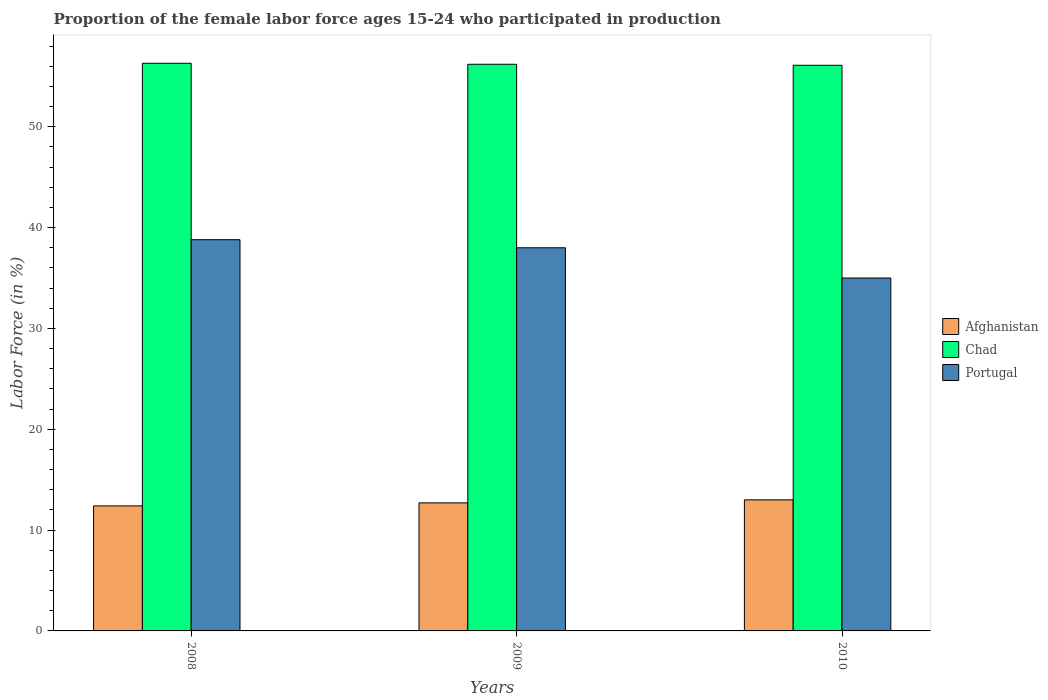How many different coloured bars are there?
Make the answer very short. 3. How many groups of bars are there?
Provide a short and direct response. 3. Are the number of bars on each tick of the X-axis equal?
Your answer should be very brief. Yes. What is the proportion of the female labor force who participated in production in Chad in 2008?
Provide a succinct answer. 56.3. Across all years, what is the maximum proportion of the female labor force who participated in production in Portugal?
Ensure brevity in your answer.  38.8. Across all years, what is the minimum proportion of the female labor force who participated in production in Chad?
Your answer should be compact. 56.1. In which year was the proportion of the female labor force who participated in production in Chad maximum?
Provide a short and direct response. 2008. What is the total proportion of the female labor force who participated in production in Chad in the graph?
Offer a very short reply. 168.6. What is the difference between the proportion of the female labor force who participated in production in Chad in 2008 and the proportion of the female labor force who participated in production in Portugal in 2009?
Your response must be concise. 18.3. What is the average proportion of the female labor force who participated in production in Portugal per year?
Give a very brief answer. 37.27. In the year 2008, what is the difference between the proportion of the female labor force who participated in production in Chad and proportion of the female labor force who participated in production in Afghanistan?
Provide a succinct answer. 43.9. In how many years, is the proportion of the female labor force who participated in production in Portugal greater than 22 %?
Give a very brief answer. 3. What is the ratio of the proportion of the female labor force who participated in production in Portugal in 2008 to that in 2010?
Provide a short and direct response. 1.11. Is the proportion of the female labor force who participated in production in Portugal in 2008 less than that in 2010?
Offer a very short reply. No. Is the difference between the proportion of the female labor force who participated in production in Chad in 2009 and 2010 greater than the difference between the proportion of the female labor force who participated in production in Afghanistan in 2009 and 2010?
Provide a short and direct response. Yes. What is the difference between the highest and the second highest proportion of the female labor force who participated in production in Chad?
Give a very brief answer. 0.1. What is the difference between the highest and the lowest proportion of the female labor force who participated in production in Chad?
Keep it short and to the point. 0.2. In how many years, is the proportion of the female labor force who participated in production in Afghanistan greater than the average proportion of the female labor force who participated in production in Afghanistan taken over all years?
Provide a succinct answer. 1. What does the 3rd bar from the right in 2009 represents?
Provide a succinct answer. Afghanistan. What is the difference between two consecutive major ticks on the Y-axis?
Keep it short and to the point. 10. Are the values on the major ticks of Y-axis written in scientific E-notation?
Offer a terse response. No. What is the title of the graph?
Keep it short and to the point. Proportion of the female labor force ages 15-24 who participated in production. What is the label or title of the X-axis?
Provide a short and direct response. Years. What is the Labor Force (in %) in Afghanistan in 2008?
Keep it short and to the point. 12.4. What is the Labor Force (in %) in Chad in 2008?
Your response must be concise. 56.3. What is the Labor Force (in %) in Portugal in 2008?
Ensure brevity in your answer.  38.8. What is the Labor Force (in %) of Afghanistan in 2009?
Your response must be concise. 12.7. What is the Labor Force (in %) of Chad in 2009?
Keep it short and to the point. 56.2. What is the Labor Force (in %) of Chad in 2010?
Ensure brevity in your answer.  56.1. Across all years, what is the maximum Labor Force (in %) of Afghanistan?
Provide a short and direct response. 13. Across all years, what is the maximum Labor Force (in %) of Chad?
Make the answer very short. 56.3. Across all years, what is the maximum Labor Force (in %) of Portugal?
Your answer should be very brief. 38.8. Across all years, what is the minimum Labor Force (in %) in Afghanistan?
Keep it short and to the point. 12.4. Across all years, what is the minimum Labor Force (in %) in Chad?
Provide a short and direct response. 56.1. What is the total Labor Force (in %) of Afghanistan in the graph?
Ensure brevity in your answer.  38.1. What is the total Labor Force (in %) in Chad in the graph?
Keep it short and to the point. 168.6. What is the total Labor Force (in %) of Portugal in the graph?
Ensure brevity in your answer.  111.8. What is the difference between the Labor Force (in %) of Afghanistan in 2008 and that in 2009?
Provide a short and direct response. -0.3. What is the difference between the Labor Force (in %) in Portugal in 2008 and that in 2010?
Provide a succinct answer. 3.8. What is the difference between the Labor Force (in %) of Chad in 2009 and that in 2010?
Make the answer very short. 0.1. What is the difference between the Labor Force (in %) of Afghanistan in 2008 and the Labor Force (in %) of Chad in 2009?
Keep it short and to the point. -43.8. What is the difference between the Labor Force (in %) of Afghanistan in 2008 and the Labor Force (in %) of Portugal in 2009?
Your answer should be very brief. -25.6. What is the difference between the Labor Force (in %) in Chad in 2008 and the Labor Force (in %) in Portugal in 2009?
Offer a terse response. 18.3. What is the difference between the Labor Force (in %) of Afghanistan in 2008 and the Labor Force (in %) of Chad in 2010?
Provide a short and direct response. -43.7. What is the difference between the Labor Force (in %) in Afghanistan in 2008 and the Labor Force (in %) in Portugal in 2010?
Offer a terse response. -22.6. What is the difference between the Labor Force (in %) in Chad in 2008 and the Labor Force (in %) in Portugal in 2010?
Make the answer very short. 21.3. What is the difference between the Labor Force (in %) in Afghanistan in 2009 and the Labor Force (in %) in Chad in 2010?
Ensure brevity in your answer.  -43.4. What is the difference between the Labor Force (in %) of Afghanistan in 2009 and the Labor Force (in %) of Portugal in 2010?
Keep it short and to the point. -22.3. What is the difference between the Labor Force (in %) of Chad in 2009 and the Labor Force (in %) of Portugal in 2010?
Your response must be concise. 21.2. What is the average Labor Force (in %) in Afghanistan per year?
Give a very brief answer. 12.7. What is the average Labor Force (in %) in Chad per year?
Give a very brief answer. 56.2. What is the average Labor Force (in %) of Portugal per year?
Keep it short and to the point. 37.27. In the year 2008, what is the difference between the Labor Force (in %) of Afghanistan and Labor Force (in %) of Chad?
Your answer should be compact. -43.9. In the year 2008, what is the difference between the Labor Force (in %) of Afghanistan and Labor Force (in %) of Portugal?
Your response must be concise. -26.4. In the year 2009, what is the difference between the Labor Force (in %) in Afghanistan and Labor Force (in %) in Chad?
Your answer should be very brief. -43.5. In the year 2009, what is the difference between the Labor Force (in %) of Afghanistan and Labor Force (in %) of Portugal?
Your answer should be compact. -25.3. In the year 2009, what is the difference between the Labor Force (in %) of Chad and Labor Force (in %) of Portugal?
Offer a terse response. 18.2. In the year 2010, what is the difference between the Labor Force (in %) of Afghanistan and Labor Force (in %) of Chad?
Keep it short and to the point. -43.1. In the year 2010, what is the difference between the Labor Force (in %) in Chad and Labor Force (in %) in Portugal?
Make the answer very short. 21.1. What is the ratio of the Labor Force (in %) in Afghanistan in 2008 to that in 2009?
Offer a very short reply. 0.98. What is the ratio of the Labor Force (in %) in Chad in 2008 to that in 2009?
Keep it short and to the point. 1. What is the ratio of the Labor Force (in %) of Portugal in 2008 to that in 2009?
Provide a short and direct response. 1.02. What is the ratio of the Labor Force (in %) in Afghanistan in 2008 to that in 2010?
Ensure brevity in your answer.  0.95. What is the ratio of the Labor Force (in %) of Chad in 2008 to that in 2010?
Keep it short and to the point. 1. What is the ratio of the Labor Force (in %) of Portugal in 2008 to that in 2010?
Provide a succinct answer. 1.11. What is the ratio of the Labor Force (in %) of Afghanistan in 2009 to that in 2010?
Provide a short and direct response. 0.98. What is the ratio of the Labor Force (in %) of Chad in 2009 to that in 2010?
Offer a terse response. 1. What is the ratio of the Labor Force (in %) in Portugal in 2009 to that in 2010?
Make the answer very short. 1.09. What is the difference between the highest and the second highest Labor Force (in %) in Chad?
Provide a short and direct response. 0.1. What is the difference between the highest and the lowest Labor Force (in %) of Afghanistan?
Offer a very short reply. 0.6. What is the difference between the highest and the lowest Labor Force (in %) in Chad?
Ensure brevity in your answer.  0.2. What is the difference between the highest and the lowest Labor Force (in %) of Portugal?
Your answer should be compact. 3.8. 